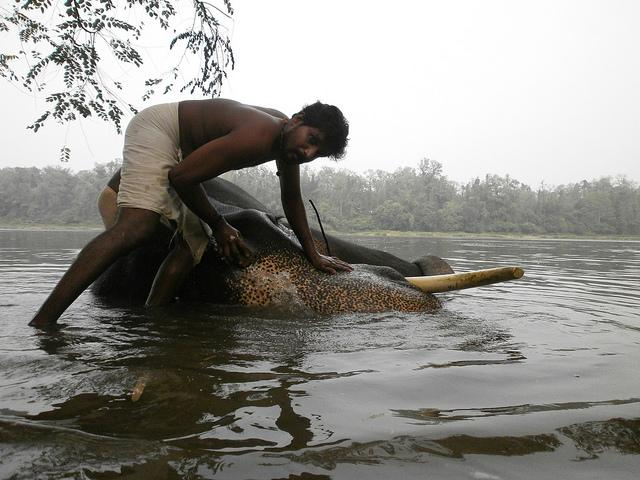What is the yellowish hard item sticking out from the animal?

Choices:
A) sword
B) handle
C) tusk
D) beating stick tusk 